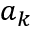Convert formula to latex. <formula><loc_0><loc_0><loc_500><loc_500>a _ { k }</formula> 